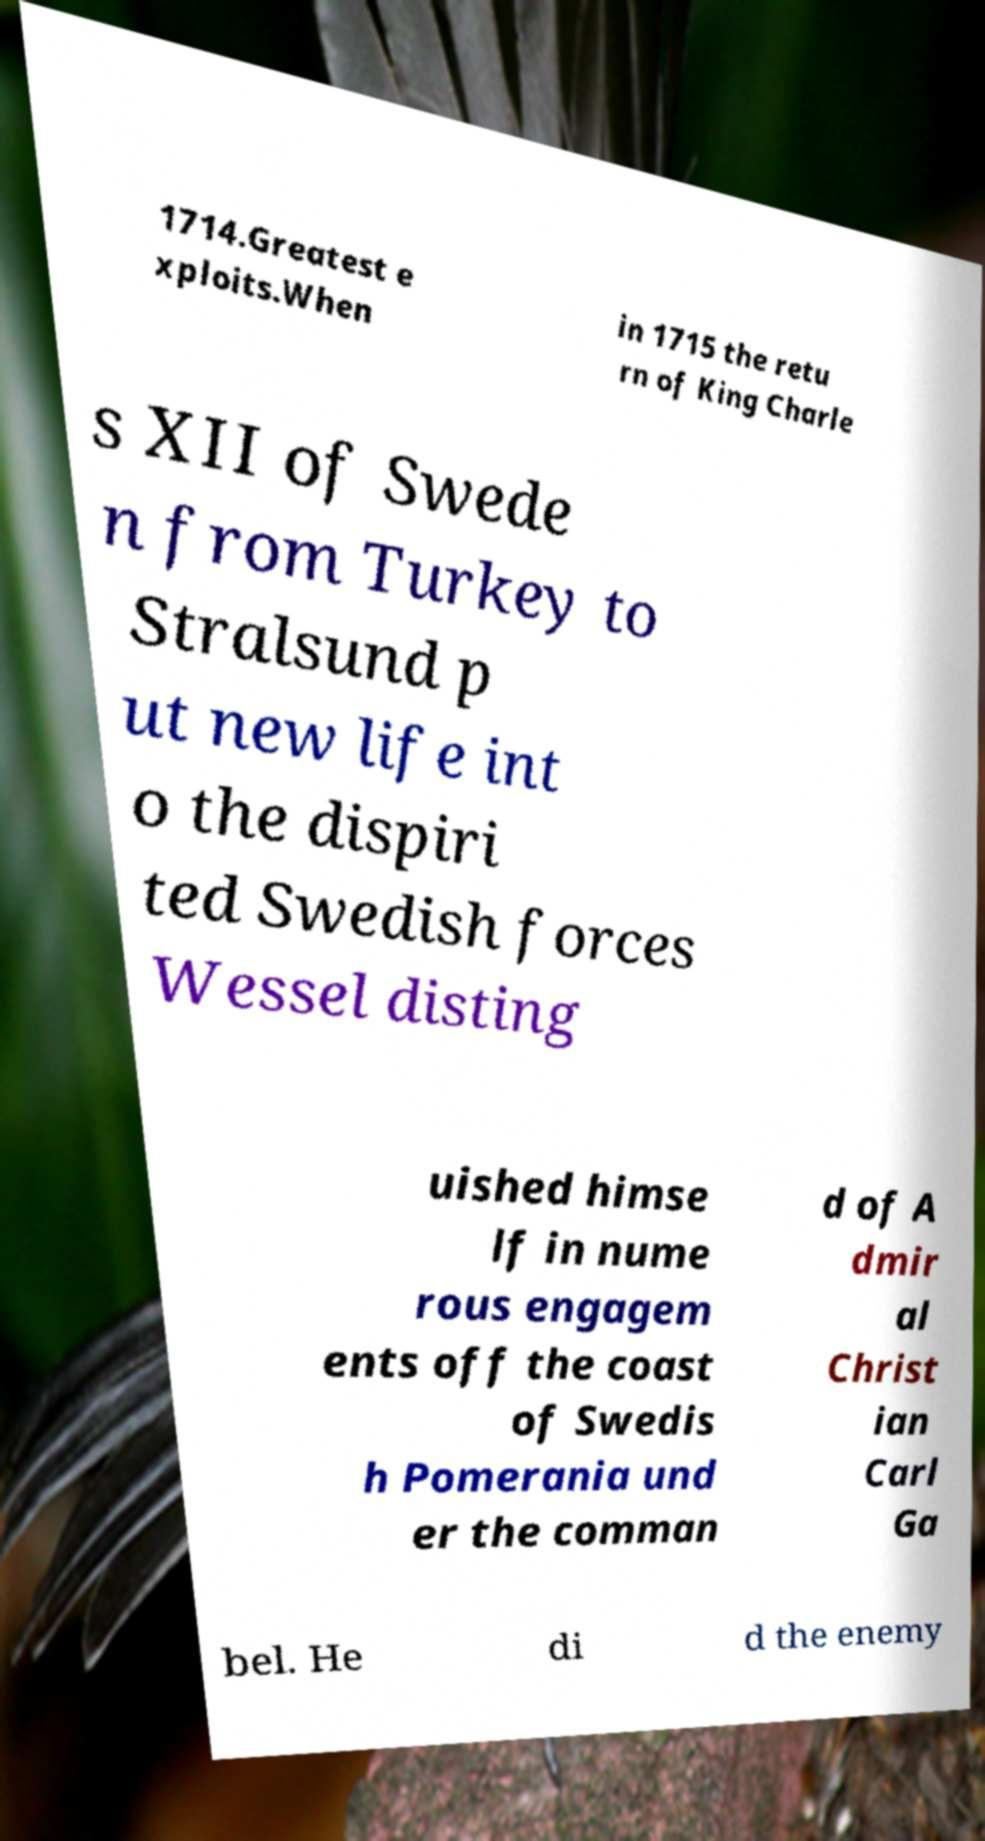For documentation purposes, I need the text within this image transcribed. Could you provide that? 1714.Greatest e xploits.When in 1715 the retu rn of King Charle s XII of Swede n from Turkey to Stralsund p ut new life int o the dispiri ted Swedish forces Wessel disting uished himse lf in nume rous engagem ents off the coast of Swedis h Pomerania und er the comman d of A dmir al Christ ian Carl Ga bel. He di d the enemy 